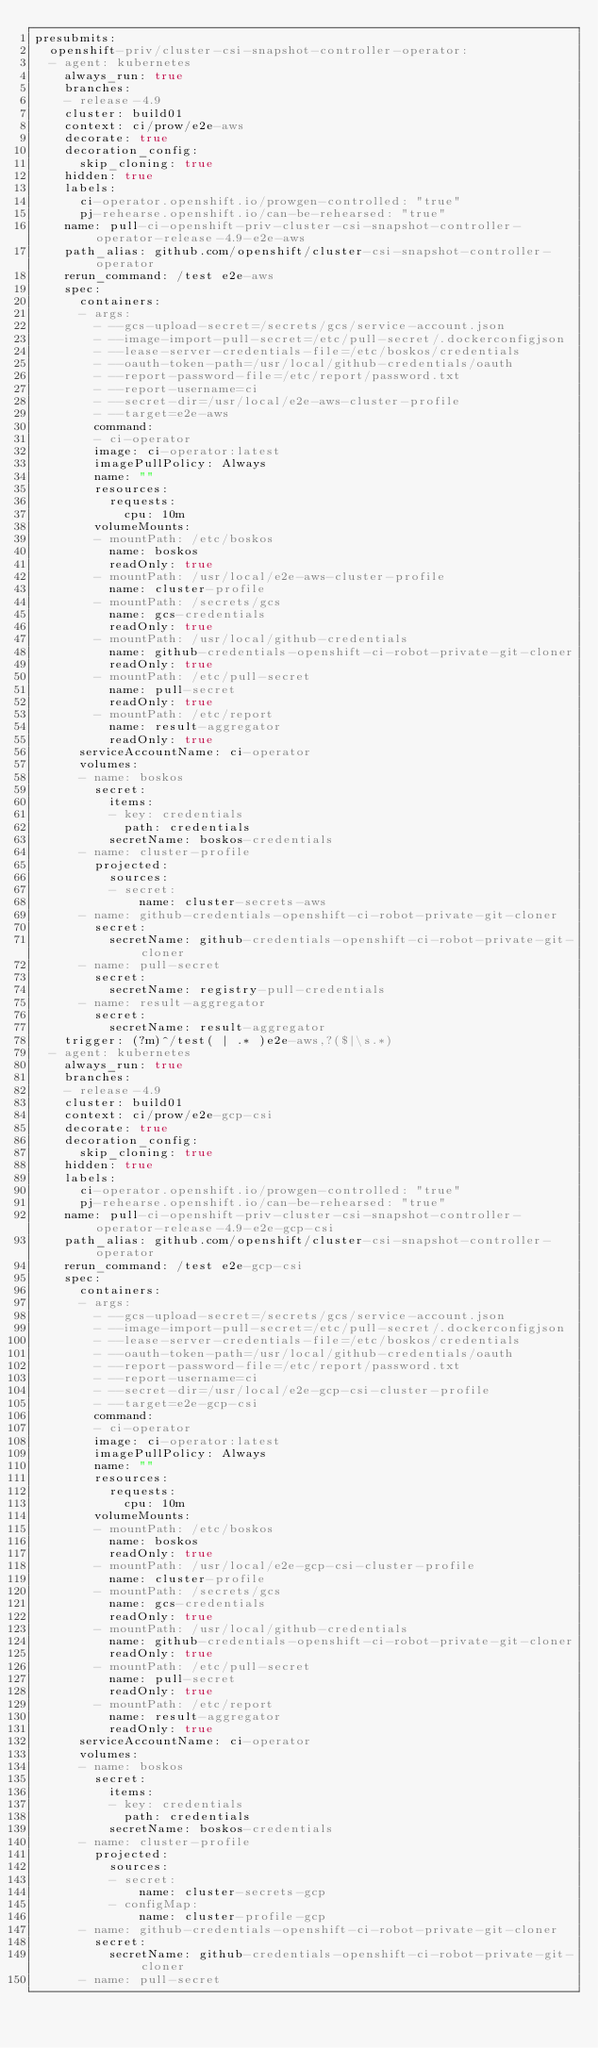<code> <loc_0><loc_0><loc_500><loc_500><_YAML_>presubmits:
  openshift-priv/cluster-csi-snapshot-controller-operator:
  - agent: kubernetes
    always_run: true
    branches:
    - release-4.9
    cluster: build01
    context: ci/prow/e2e-aws
    decorate: true
    decoration_config:
      skip_cloning: true
    hidden: true
    labels:
      ci-operator.openshift.io/prowgen-controlled: "true"
      pj-rehearse.openshift.io/can-be-rehearsed: "true"
    name: pull-ci-openshift-priv-cluster-csi-snapshot-controller-operator-release-4.9-e2e-aws
    path_alias: github.com/openshift/cluster-csi-snapshot-controller-operator
    rerun_command: /test e2e-aws
    spec:
      containers:
      - args:
        - --gcs-upload-secret=/secrets/gcs/service-account.json
        - --image-import-pull-secret=/etc/pull-secret/.dockerconfigjson
        - --lease-server-credentials-file=/etc/boskos/credentials
        - --oauth-token-path=/usr/local/github-credentials/oauth
        - --report-password-file=/etc/report/password.txt
        - --report-username=ci
        - --secret-dir=/usr/local/e2e-aws-cluster-profile
        - --target=e2e-aws
        command:
        - ci-operator
        image: ci-operator:latest
        imagePullPolicy: Always
        name: ""
        resources:
          requests:
            cpu: 10m
        volumeMounts:
        - mountPath: /etc/boskos
          name: boskos
          readOnly: true
        - mountPath: /usr/local/e2e-aws-cluster-profile
          name: cluster-profile
        - mountPath: /secrets/gcs
          name: gcs-credentials
          readOnly: true
        - mountPath: /usr/local/github-credentials
          name: github-credentials-openshift-ci-robot-private-git-cloner
          readOnly: true
        - mountPath: /etc/pull-secret
          name: pull-secret
          readOnly: true
        - mountPath: /etc/report
          name: result-aggregator
          readOnly: true
      serviceAccountName: ci-operator
      volumes:
      - name: boskos
        secret:
          items:
          - key: credentials
            path: credentials
          secretName: boskos-credentials
      - name: cluster-profile
        projected:
          sources:
          - secret:
              name: cluster-secrets-aws
      - name: github-credentials-openshift-ci-robot-private-git-cloner
        secret:
          secretName: github-credentials-openshift-ci-robot-private-git-cloner
      - name: pull-secret
        secret:
          secretName: registry-pull-credentials
      - name: result-aggregator
        secret:
          secretName: result-aggregator
    trigger: (?m)^/test( | .* )e2e-aws,?($|\s.*)
  - agent: kubernetes
    always_run: true
    branches:
    - release-4.9
    cluster: build01
    context: ci/prow/e2e-gcp-csi
    decorate: true
    decoration_config:
      skip_cloning: true
    hidden: true
    labels:
      ci-operator.openshift.io/prowgen-controlled: "true"
      pj-rehearse.openshift.io/can-be-rehearsed: "true"
    name: pull-ci-openshift-priv-cluster-csi-snapshot-controller-operator-release-4.9-e2e-gcp-csi
    path_alias: github.com/openshift/cluster-csi-snapshot-controller-operator
    rerun_command: /test e2e-gcp-csi
    spec:
      containers:
      - args:
        - --gcs-upload-secret=/secrets/gcs/service-account.json
        - --image-import-pull-secret=/etc/pull-secret/.dockerconfigjson
        - --lease-server-credentials-file=/etc/boskos/credentials
        - --oauth-token-path=/usr/local/github-credentials/oauth
        - --report-password-file=/etc/report/password.txt
        - --report-username=ci
        - --secret-dir=/usr/local/e2e-gcp-csi-cluster-profile
        - --target=e2e-gcp-csi
        command:
        - ci-operator
        image: ci-operator:latest
        imagePullPolicy: Always
        name: ""
        resources:
          requests:
            cpu: 10m
        volumeMounts:
        - mountPath: /etc/boskos
          name: boskos
          readOnly: true
        - mountPath: /usr/local/e2e-gcp-csi-cluster-profile
          name: cluster-profile
        - mountPath: /secrets/gcs
          name: gcs-credentials
          readOnly: true
        - mountPath: /usr/local/github-credentials
          name: github-credentials-openshift-ci-robot-private-git-cloner
          readOnly: true
        - mountPath: /etc/pull-secret
          name: pull-secret
          readOnly: true
        - mountPath: /etc/report
          name: result-aggregator
          readOnly: true
      serviceAccountName: ci-operator
      volumes:
      - name: boskos
        secret:
          items:
          - key: credentials
            path: credentials
          secretName: boskos-credentials
      - name: cluster-profile
        projected:
          sources:
          - secret:
              name: cluster-secrets-gcp
          - configMap:
              name: cluster-profile-gcp
      - name: github-credentials-openshift-ci-robot-private-git-cloner
        secret:
          secretName: github-credentials-openshift-ci-robot-private-git-cloner
      - name: pull-secret</code> 